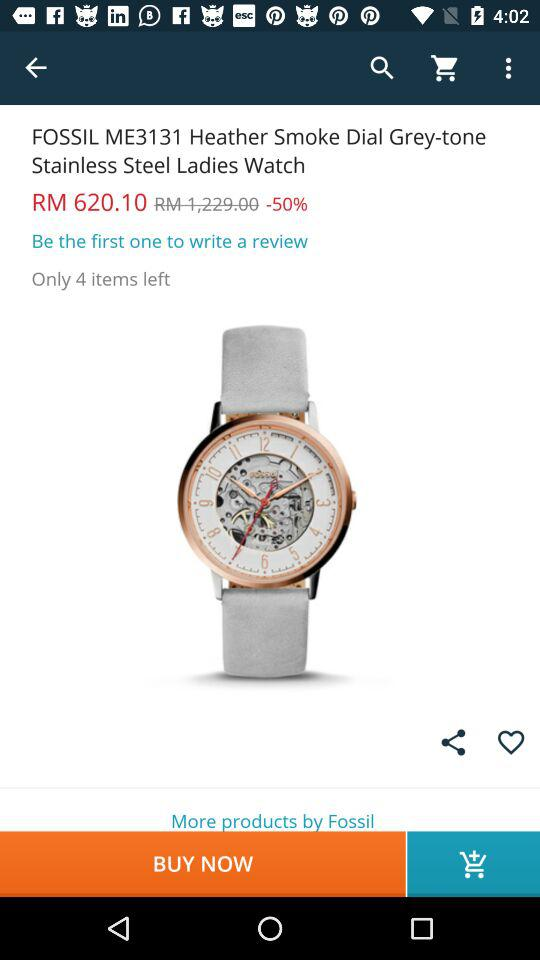What is the price of "FOSSIL ME3131"? The price is RM620.10. 